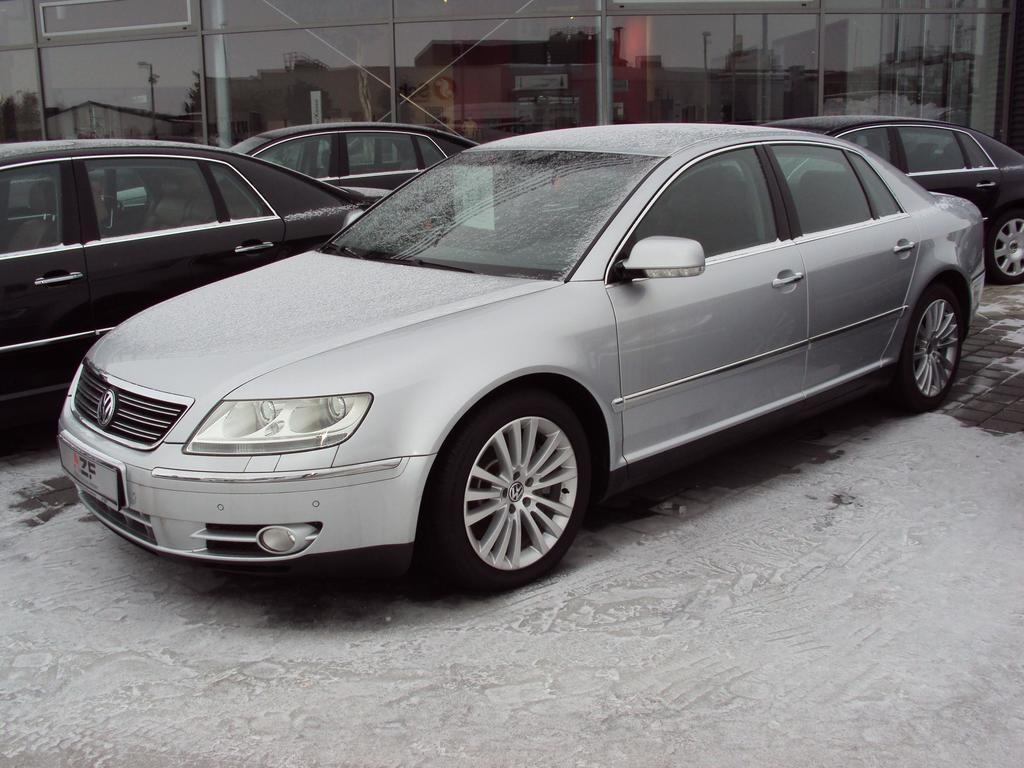What is the main subject in the foreground of the image? There is a car in the foreground of the image. What is the car's location in relation to the pavement and snow? The car is on the pavement and snow. How many cars can be seen in the background of the image? There are three cars in the background of the image. What type of structure is visible in the background? There is a glass building in the background of the image. What type of coat is the page wearing in the image? There is no person wearing a coat or holding a page in the image. 